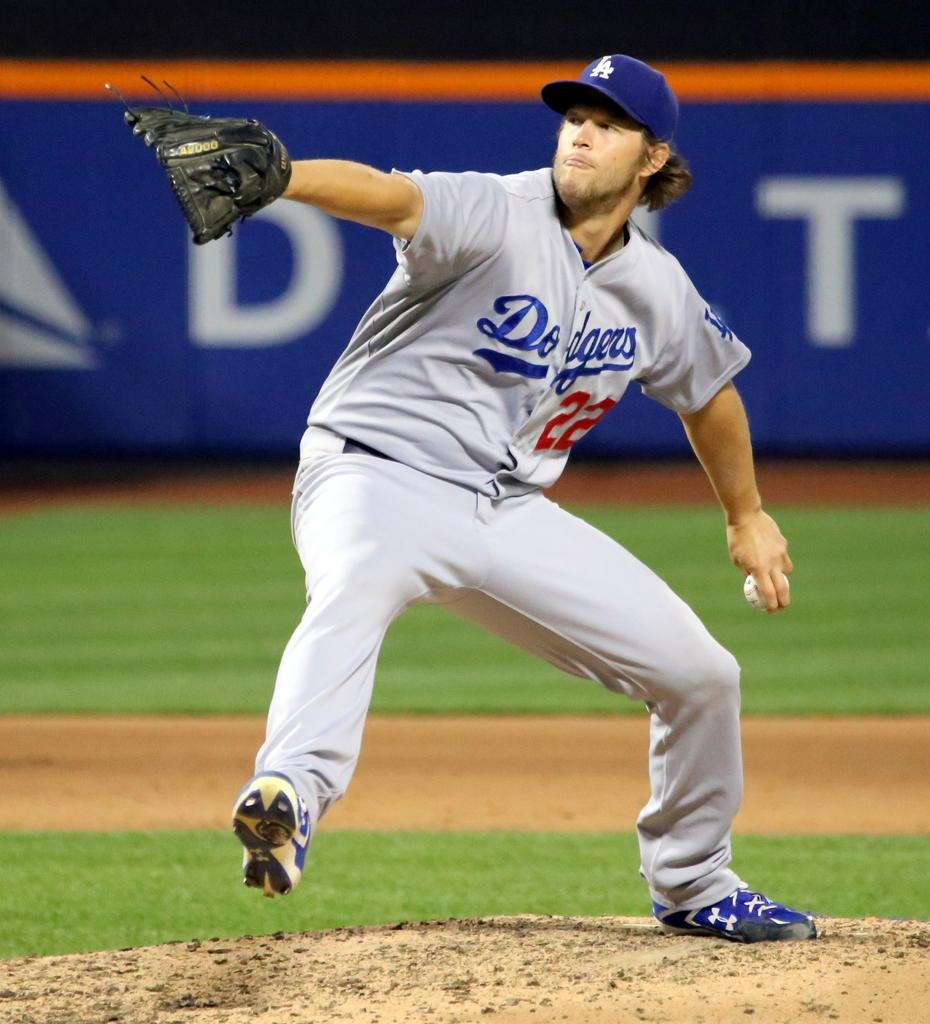Provide a one-sentence caption for the provided image. The LA Dodgers pitcher is on the mound getting ready to make a pitch. 